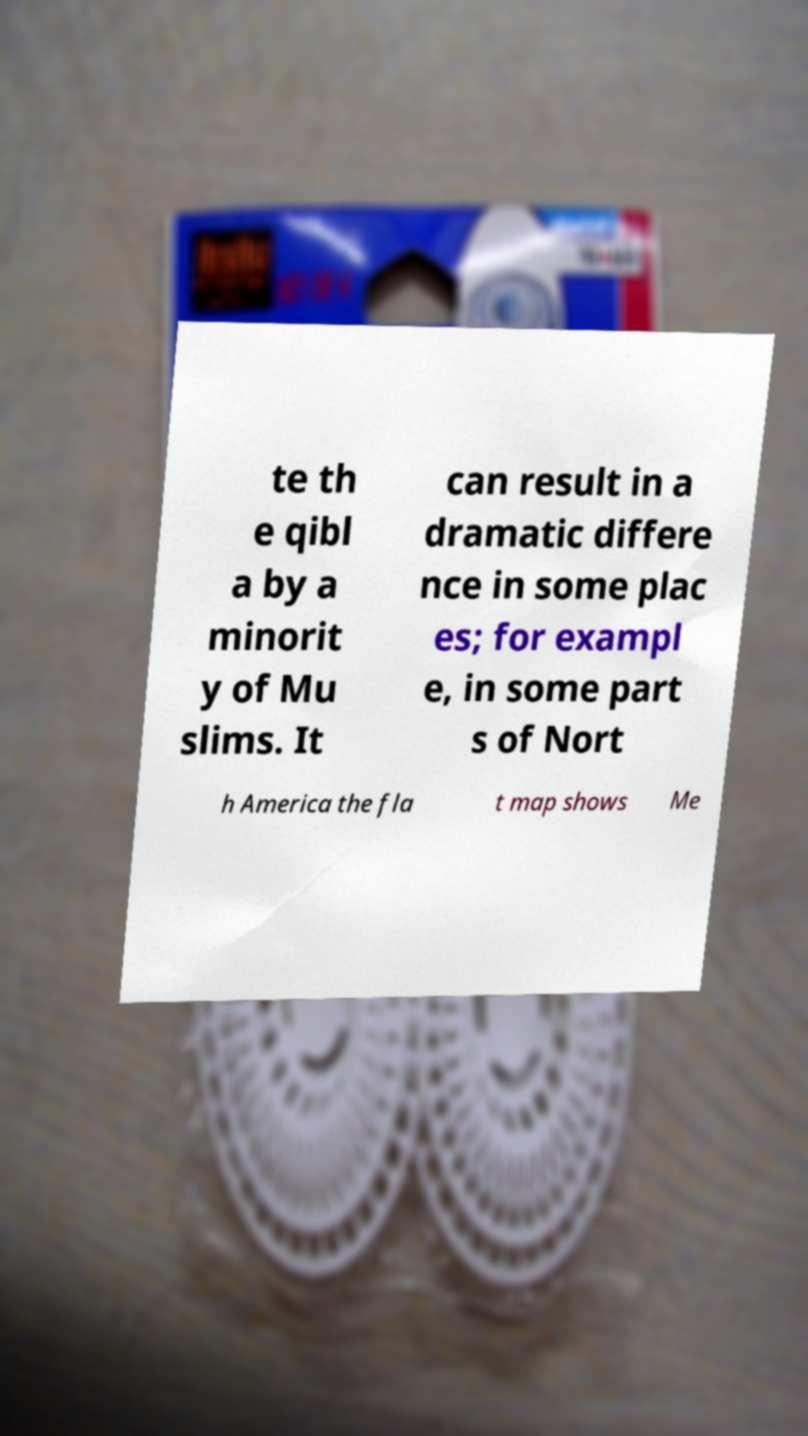What messages or text are displayed in this image? I need them in a readable, typed format. te th e qibl a by a minorit y of Mu slims. It can result in a dramatic differe nce in some plac es; for exampl e, in some part s of Nort h America the fla t map shows Me 